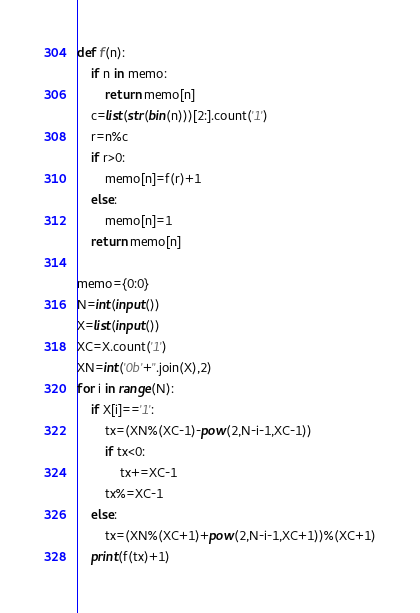Convert code to text. <code><loc_0><loc_0><loc_500><loc_500><_Python_>def f(n):
    if n in memo:
        return memo[n]
    c=list(str(bin(n)))[2:].count('1')
    r=n%c
    if r>0:
        memo[n]=f(r)+1
    else:
        memo[n]=1
    return memo[n]

memo={0:0}
N=int(input())
X=list(input())
XC=X.count('1')
XN=int('0b'+''.join(X),2)
for i in range(N):
    if X[i]=='1':
        tx=(XN%(XC-1)-pow(2,N-i-1,XC-1))
        if tx<0:
            tx+=XC-1
        tx%=XC-1
    else:
        tx=(XN%(XC+1)+pow(2,N-i-1,XC+1))%(XC+1)
    print(f(tx)+1)</code> 